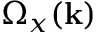Convert formula to latex. <formula><loc_0><loc_0><loc_500><loc_500>\Omega _ { x } ( k )</formula> 